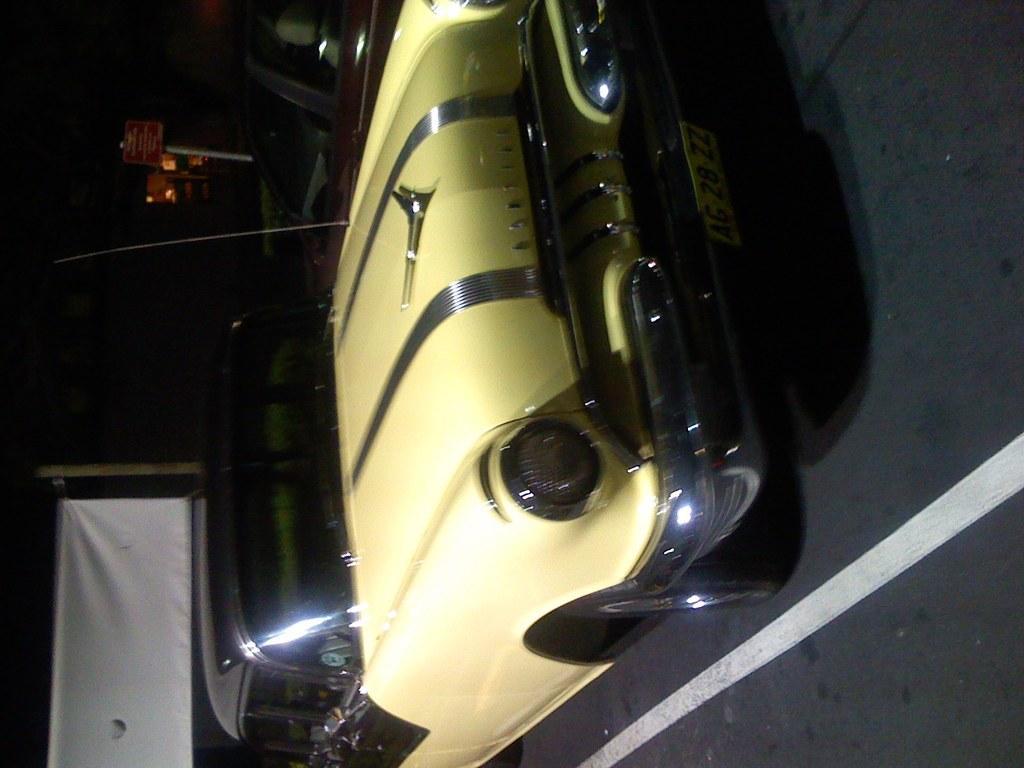Describe this image in one or two sentences. In this picture we can see a car on the road and in the background we can see a banner, board, some objects and it is dark. 